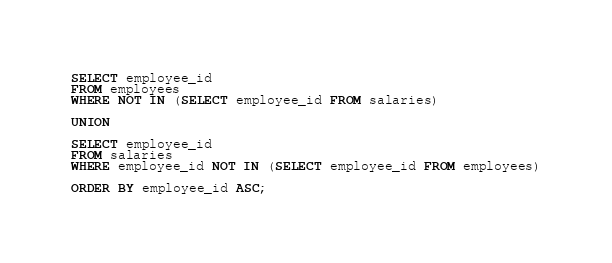<code> <loc_0><loc_0><loc_500><loc_500><_SQL_>SELECT employee_id 
FROM employees
WHERE NOT IN (SELECT employee_id FROM salaries)

UNION

SELECT employee_id 
FROM salaries
WHERE employee_id NOT IN (SELECT employee_id FROM employees)

ORDER BY employee_id ASC;
</code> 